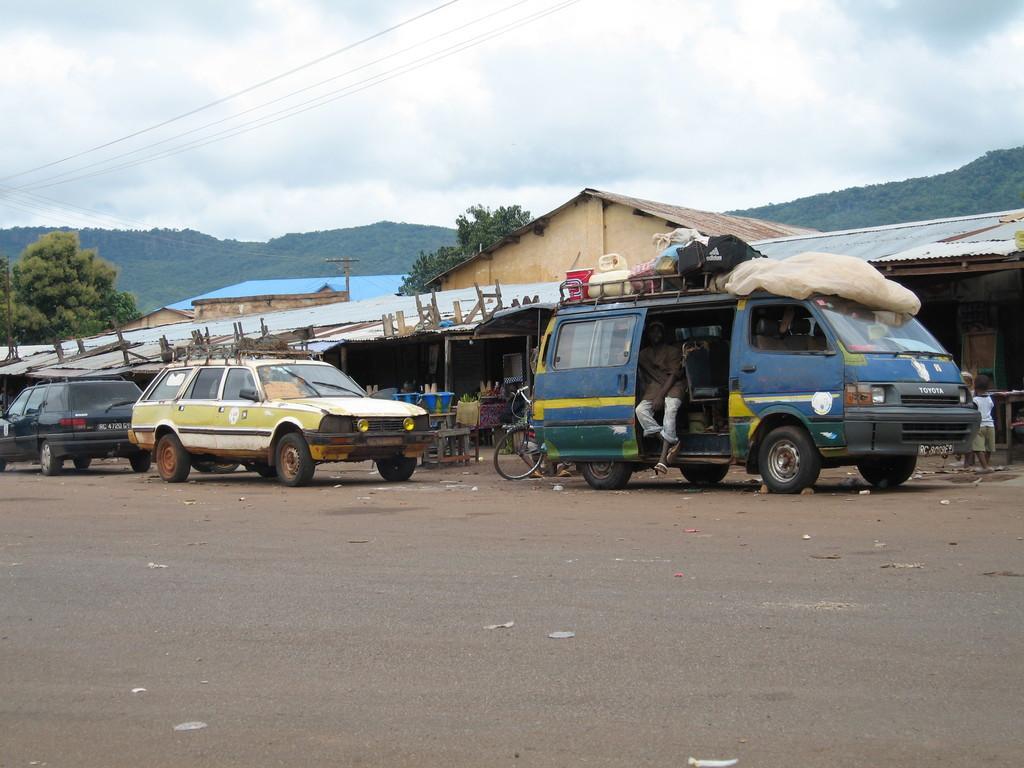Please provide a concise description of this image. In this picture we can see vehicles on the road, trees, sheds, wires and in the background we can see the sky with clouds. 